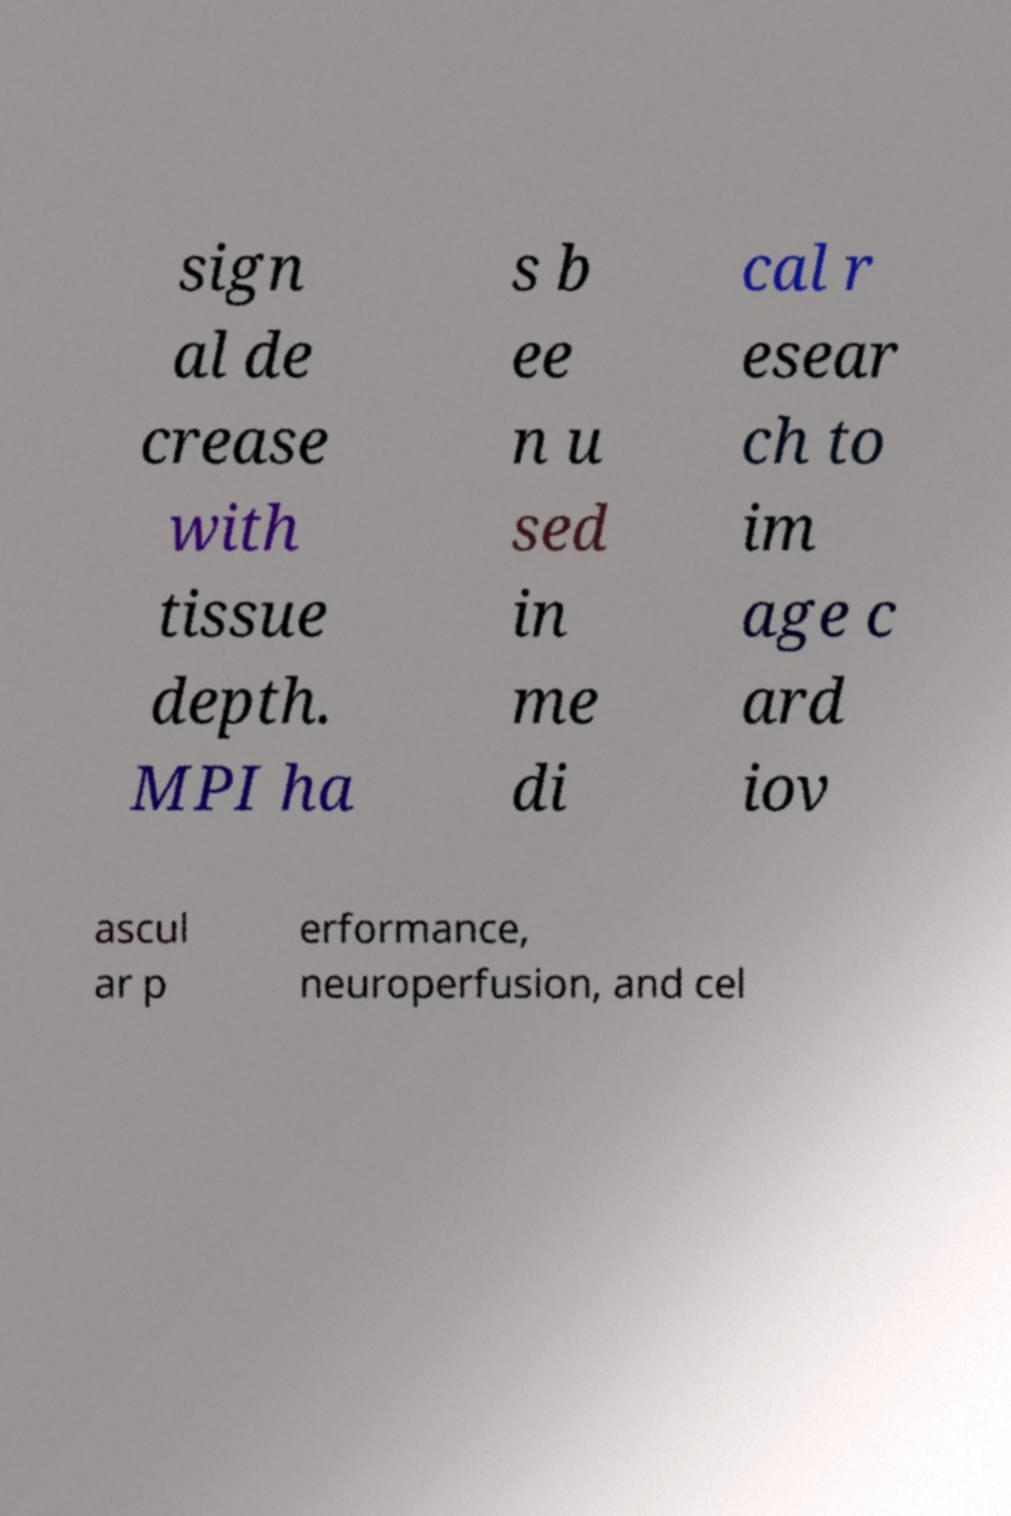Can you accurately transcribe the text from the provided image for me? sign al de crease with tissue depth. MPI ha s b ee n u sed in me di cal r esear ch to im age c ard iov ascul ar p erformance, neuroperfusion, and cel 